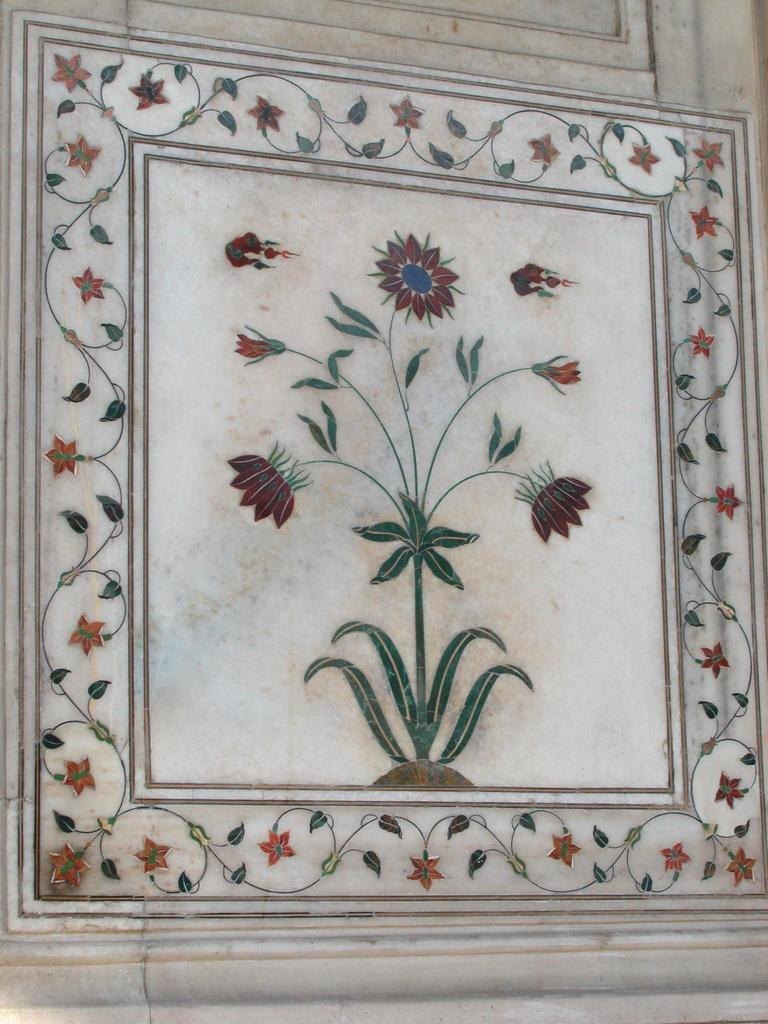What is depicted in the painting that is visible in the image? There is a painting of a plant in the image. What specific elements are included in the painting? The painting includes flowers and leaves. Where is the painting located in the image? The painting is on the wall. How many ears of corn can be seen in the painting? There are no ears of corn depicted in the painting; it features flowers and leaves. What type of head is visible on the plant in the painting? The painting does not depict a plant with a head; it features flowers and leaves. 